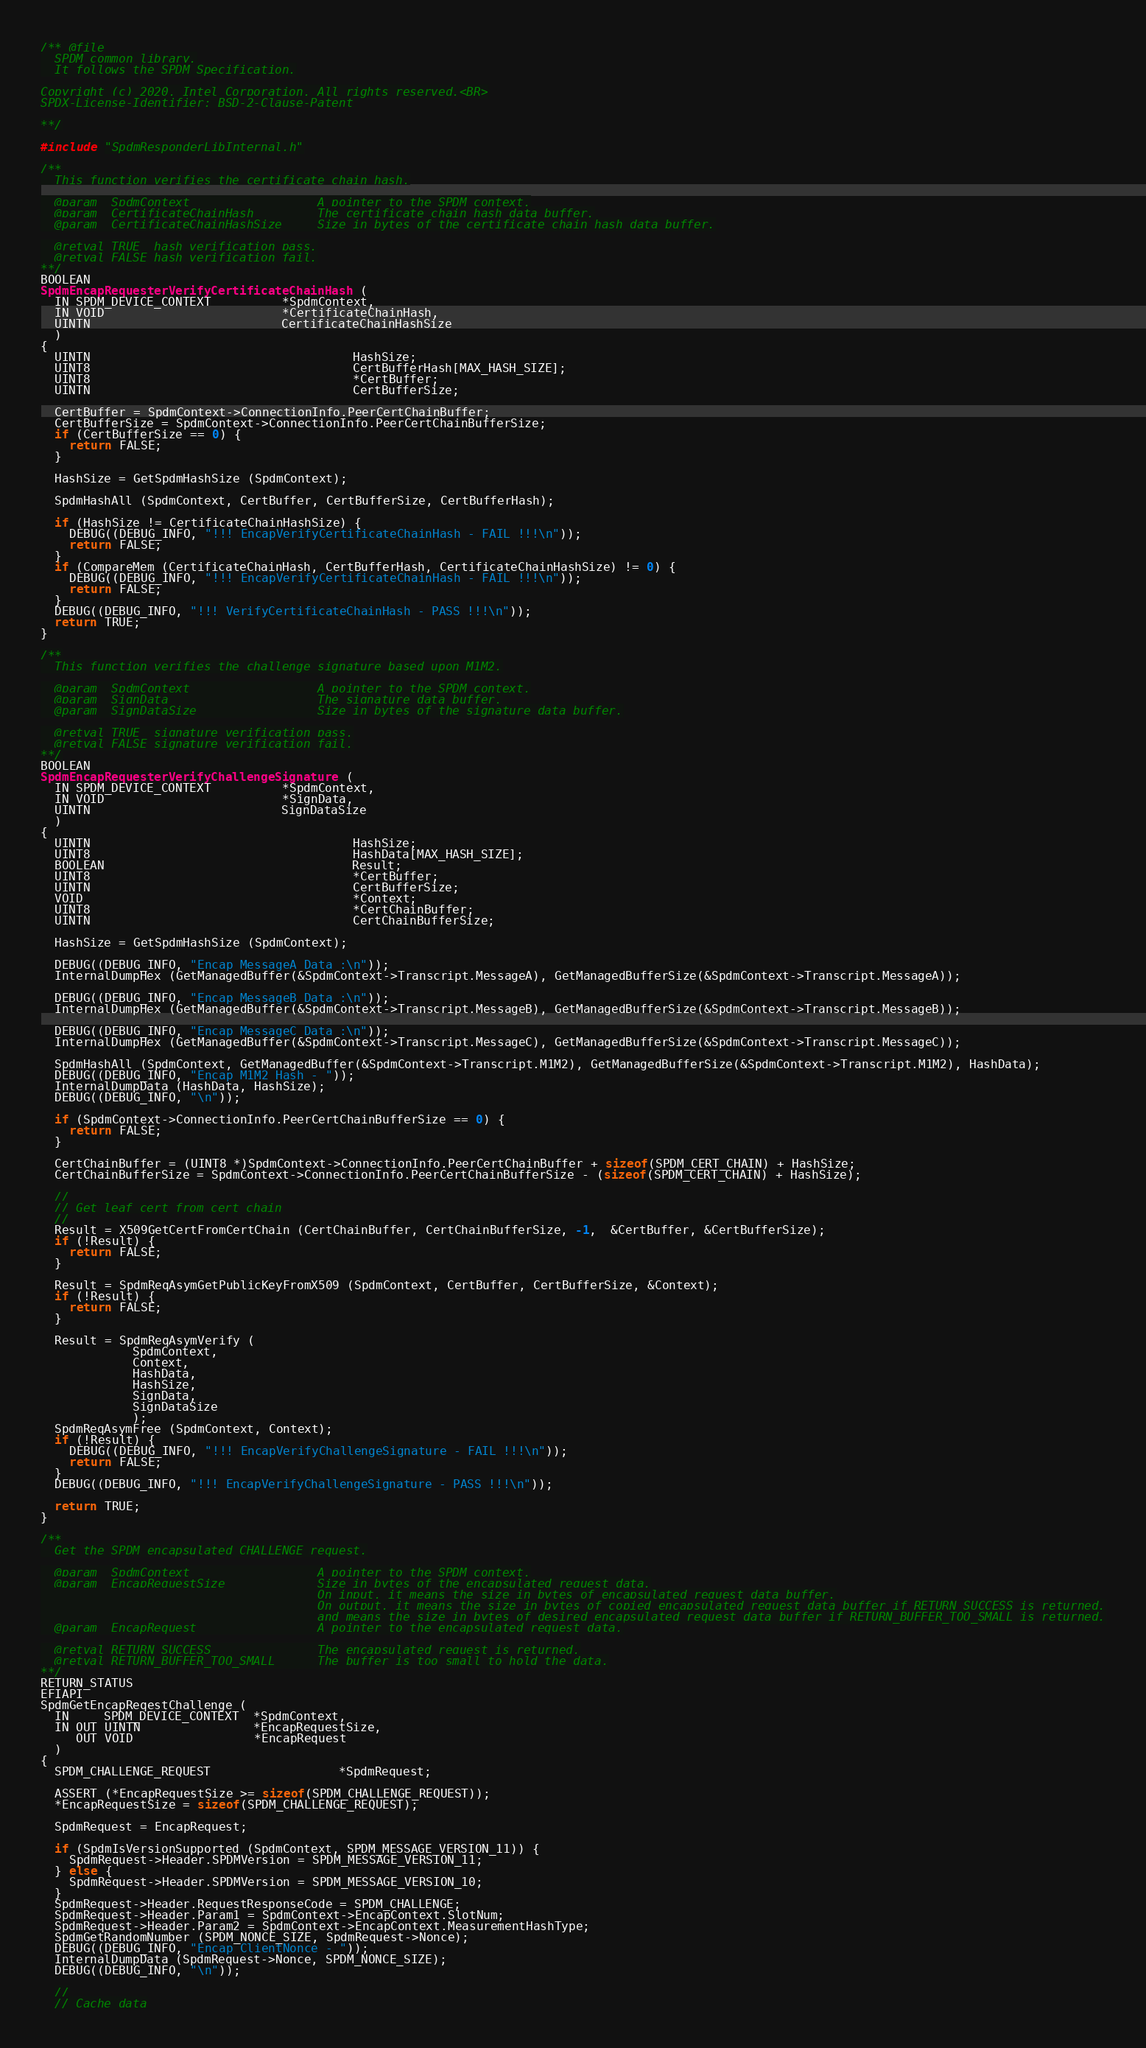<code> <loc_0><loc_0><loc_500><loc_500><_C_>/** @file
  SPDM common library.
  It follows the SPDM Specification.

Copyright (c) 2020, Intel Corporation. All rights reserved.<BR>
SPDX-License-Identifier: BSD-2-Clause-Patent

**/

#include "SpdmResponderLibInternal.h"

/**
  This function verifies the certificate chain hash.

  @param  SpdmContext                  A pointer to the SPDM context.
  @param  CertificateChainHash         The certificate chain hash data buffer.
  @param  CertificateChainHashSize     Size in bytes of the certificate chain hash data buffer.

  @retval TRUE  hash verification pass.
  @retval FALSE hash verification fail.
**/
BOOLEAN
SpdmEncapRequesterVerifyCertificateChainHash (
  IN SPDM_DEVICE_CONTEXT          *SpdmContext,
  IN VOID                         *CertificateChainHash,
  UINTN                           CertificateChainHashSize
  )
{
  UINTN                                     HashSize;
  UINT8                                     CertBufferHash[MAX_HASH_SIZE];
  UINT8                                     *CertBuffer;
  UINTN                                     CertBufferSize;

  CertBuffer = SpdmContext->ConnectionInfo.PeerCertChainBuffer;
  CertBufferSize = SpdmContext->ConnectionInfo.PeerCertChainBufferSize;
  if (CertBufferSize == 0) {
    return FALSE;
  }

  HashSize = GetSpdmHashSize (SpdmContext);

  SpdmHashAll (SpdmContext, CertBuffer, CertBufferSize, CertBufferHash);

  if (HashSize != CertificateChainHashSize) {
    DEBUG((DEBUG_INFO, "!!! EncapVerifyCertificateChainHash - FAIL !!!\n"));
    return FALSE;
  }
  if (CompareMem (CertificateChainHash, CertBufferHash, CertificateChainHashSize) != 0) {
    DEBUG((DEBUG_INFO, "!!! EncapVerifyCertificateChainHash - FAIL !!!\n"));
    return FALSE;
  }
  DEBUG((DEBUG_INFO, "!!! VerifyCertificateChainHash - PASS !!!\n"));
  return TRUE;
}

/**
  This function verifies the challenge signature based upon M1M2.

  @param  SpdmContext                  A pointer to the SPDM context.
  @param  SignData                     The signature data buffer.
  @param  SignDataSize                 Size in bytes of the signature data buffer.

  @retval TRUE  signature verification pass.
  @retval FALSE signature verification fail.
**/
BOOLEAN
SpdmEncapRequesterVerifyChallengeSignature (
  IN SPDM_DEVICE_CONTEXT          *SpdmContext,
  IN VOID                         *SignData,
  UINTN                           SignDataSize
  )
{
  UINTN                                     HashSize;
  UINT8                                     HashData[MAX_HASH_SIZE];
  BOOLEAN                                   Result;
  UINT8                                     *CertBuffer;
  UINTN                                     CertBufferSize;
  VOID                                      *Context;
  UINT8                                     *CertChainBuffer;
  UINTN                                     CertChainBufferSize;

  HashSize = GetSpdmHashSize (SpdmContext);

  DEBUG((DEBUG_INFO, "Encap MessageA Data :\n"));
  InternalDumpHex (GetManagedBuffer(&SpdmContext->Transcript.MessageA), GetManagedBufferSize(&SpdmContext->Transcript.MessageA));

  DEBUG((DEBUG_INFO, "Encap MessageB Data :\n"));
  InternalDumpHex (GetManagedBuffer(&SpdmContext->Transcript.MessageB), GetManagedBufferSize(&SpdmContext->Transcript.MessageB));

  DEBUG((DEBUG_INFO, "Encap MessageC Data :\n"));
  InternalDumpHex (GetManagedBuffer(&SpdmContext->Transcript.MessageC), GetManagedBufferSize(&SpdmContext->Transcript.MessageC));

  SpdmHashAll (SpdmContext, GetManagedBuffer(&SpdmContext->Transcript.M1M2), GetManagedBufferSize(&SpdmContext->Transcript.M1M2), HashData);
  DEBUG((DEBUG_INFO, "Encap M1M2 Hash - "));
  InternalDumpData (HashData, HashSize);
  DEBUG((DEBUG_INFO, "\n"));

  if (SpdmContext->ConnectionInfo.PeerCertChainBufferSize == 0) {
    return FALSE;
  }

  CertChainBuffer = (UINT8 *)SpdmContext->ConnectionInfo.PeerCertChainBuffer + sizeof(SPDM_CERT_CHAIN) + HashSize;
  CertChainBufferSize = SpdmContext->ConnectionInfo.PeerCertChainBufferSize - (sizeof(SPDM_CERT_CHAIN) + HashSize);

  //
  // Get leaf cert from cert chain
  //
  Result = X509GetCertFromCertChain (CertChainBuffer, CertChainBufferSize, -1,  &CertBuffer, &CertBufferSize);
  if (!Result) {
    return FALSE;
  }

  Result = SpdmReqAsymGetPublicKeyFromX509 (SpdmContext, CertBuffer, CertBufferSize, &Context);
  if (!Result) {
    return FALSE;
  }

  Result = SpdmReqAsymVerify (
             SpdmContext,
             Context,
             HashData,
             HashSize,
             SignData,
             SignDataSize
             );
  SpdmReqAsymFree (SpdmContext, Context);
  if (!Result) {
    DEBUG((DEBUG_INFO, "!!! EncapVerifyChallengeSignature - FAIL !!!\n"));
    return FALSE;
  }
  DEBUG((DEBUG_INFO, "!!! EncapVerifyChallengeSignature - PASS !!!\n"));

  return TRUE;
}

/**
  Get the SPDM encapsulated CHALLENGE request.

  @param  SpdmContext                  A pointer to the SPDM context.
  @param  EncapRequestSize             Size in bytes of the encapsulated request data.
                                       On input, it means the size in bytes of encapsulated request data buffer.
                                       On output, it means the size in bytes of copied encapsulated request data buffer if RETURN_SUCCESS is returned,
                                       and means the size in bytes of desired encapsulated request data buffer if RETURN_BUFFER_TOO_SMALL is returned.
  @param  EncapRequest                 A pointer to the encapsulated request data.

  @retval RETURN_SUCCESS               The encapsulated request is returned.
  @retval RETURN_BUFFER_TOO_SMALL      The buffer is too small to hold the data.
**/
RETURN_STATUS
EFIAPI
SpdmGetEncapReqestChallenge (
  IN     SPDM_DEVICE_CONTEXT  *SpdmContext,
  IN OUT UINTN                *EncapRequestSize,
     OUT VOID                 *EncapRequest
  )
{
  SPDM_CHALLENGE_REQUEST                  *SpdmRequest;

  ASSERT (*EncapRequestSize >= sizeof(SPDM_CHALLENGE_REQUEST));
  *EncapRequestSize = sizeof(SPDM_CHALLENGE_REQUEST);

  SpdmRequest = EncapRequest;

  if (SpdmIsVersionSupported (SpdmContext, SPDM_MESSAGE_VERSION_11)) {
    SpdmRequest->Header.SPDMVersion = SPDM_MESSAGE_VERSION_11;
  } else {
    SpdmRequest->Header.SPDMVersion = SPDM_MESSAGE_VERSION_10;
  }
  SpdmRequest->Header.RequestResponseCode = SPDM_CHALLENGE;
  SpdmRequest->Header.Param1 = SpdmContext->EncapContext.SlotNum;
  SpdmRequest->Header.Param2 = SpdmContext->EncapContext.MeasurementHashType;
  SpdmGetRandomNumber (SPDM_NONCE_SIZE, SpdmRequest->Nonce);
  DEBUG((DEBUG_INFO, "Encap ClientNonce - "));
  InternalDumpData (SpdmRequest->Nonce, SPDM_NONCE_SIZE);
  DEBUG((DEBUG_INFO, "\n"));

  //
  // Cache data</code> 